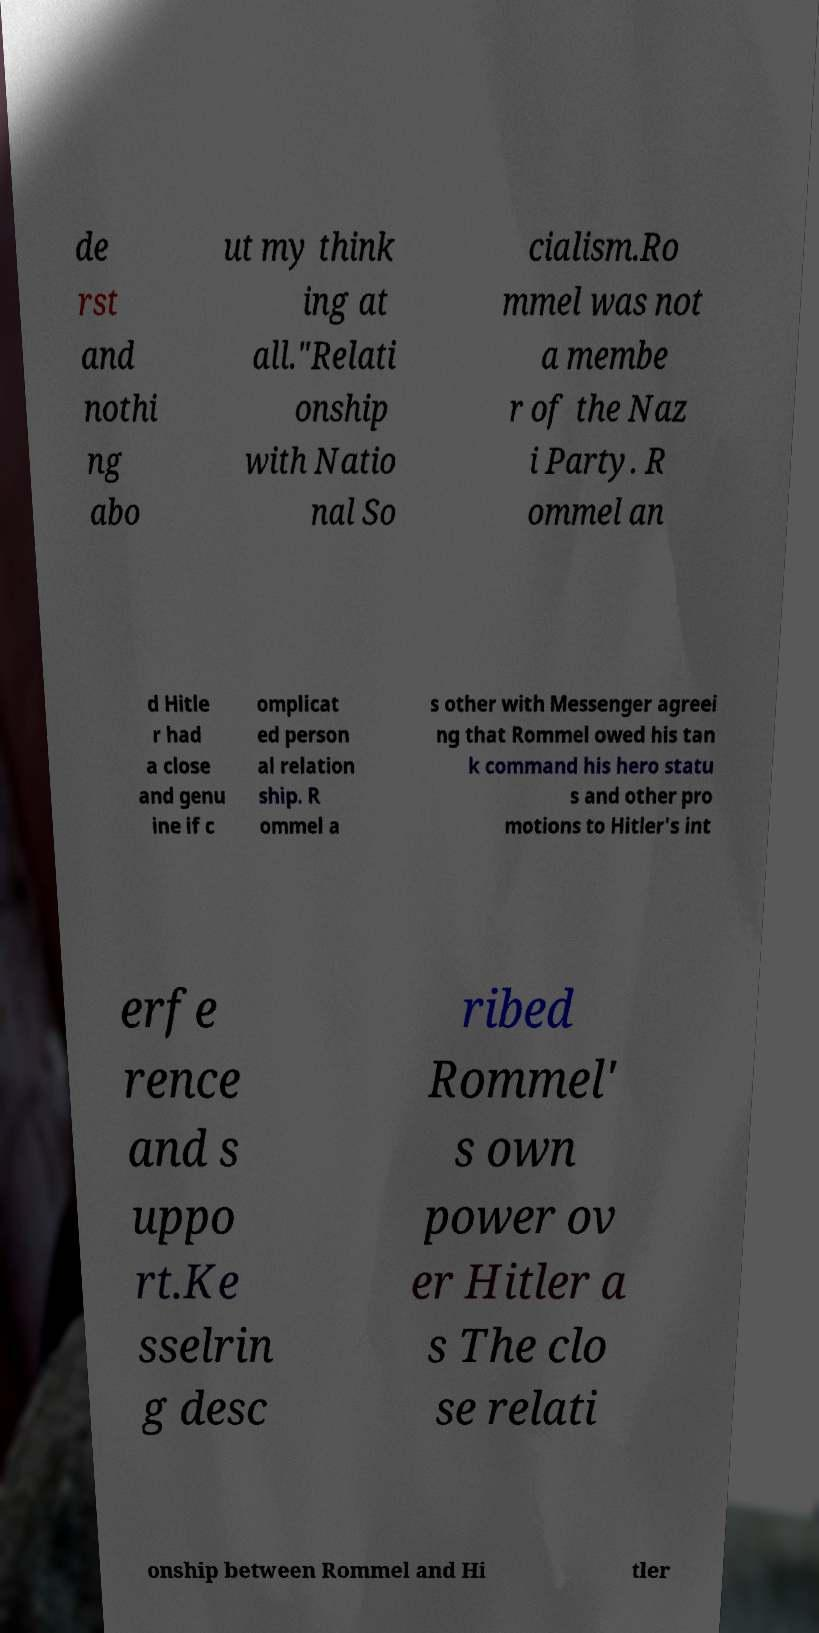I need the written content from this picture converted into text. Can you do that? de rst and nothi ng abo ut my think ing at all."Relati onship with Natio nal So cialism.Ro mmel was not a membe r of the Naz i Party. R ommel an d Hitle r had a close and genu ine if c omplicat ed person al relation ship. R ommel a s other with Messenger agreei ng that Rommel owed his tan k command his hero statu s and other pro motions to Hitler's int erfe rence and s uppo rt.Ke sselrin g desc ribed Rommel' s own power ov er Hitler a s The clo se relati onship between Rommel and Hi tler 